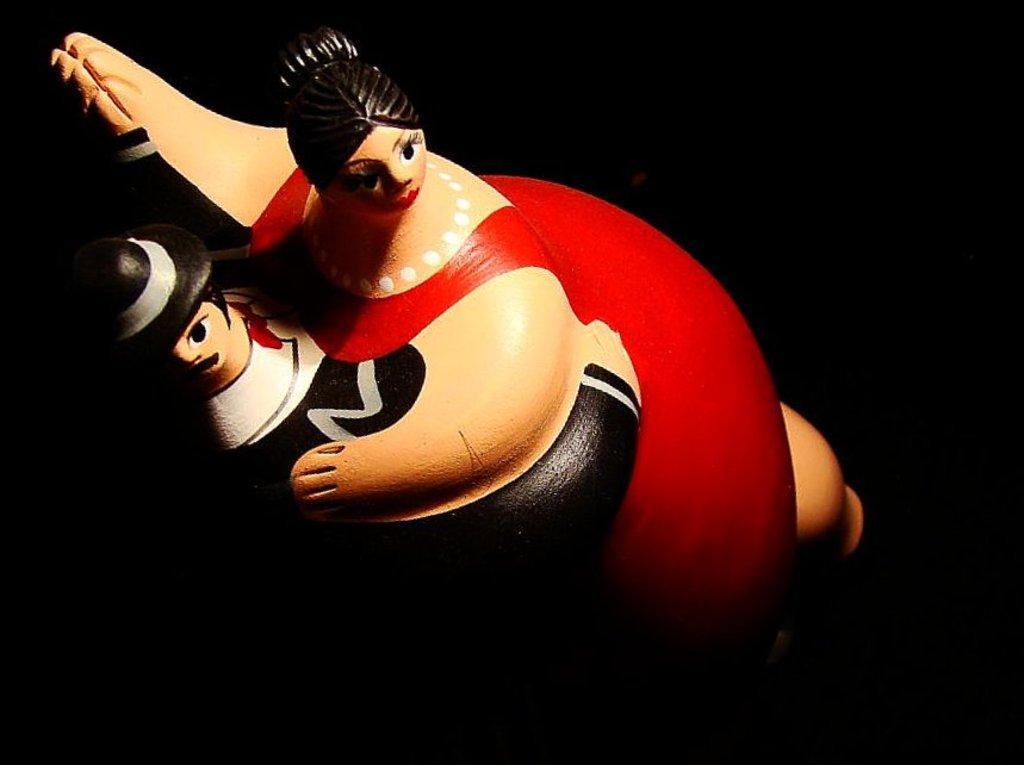Describe this image in one or two sentences. There is a toy in the middle of this image, and it is dark in the background. 